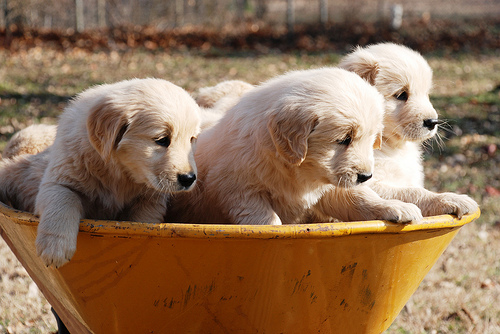<image>
Is there a puppies on the ground? No. The puppies is not positioned on the ground. They may be near each other, but the puppies is not supported by or resting on top of the ground. 